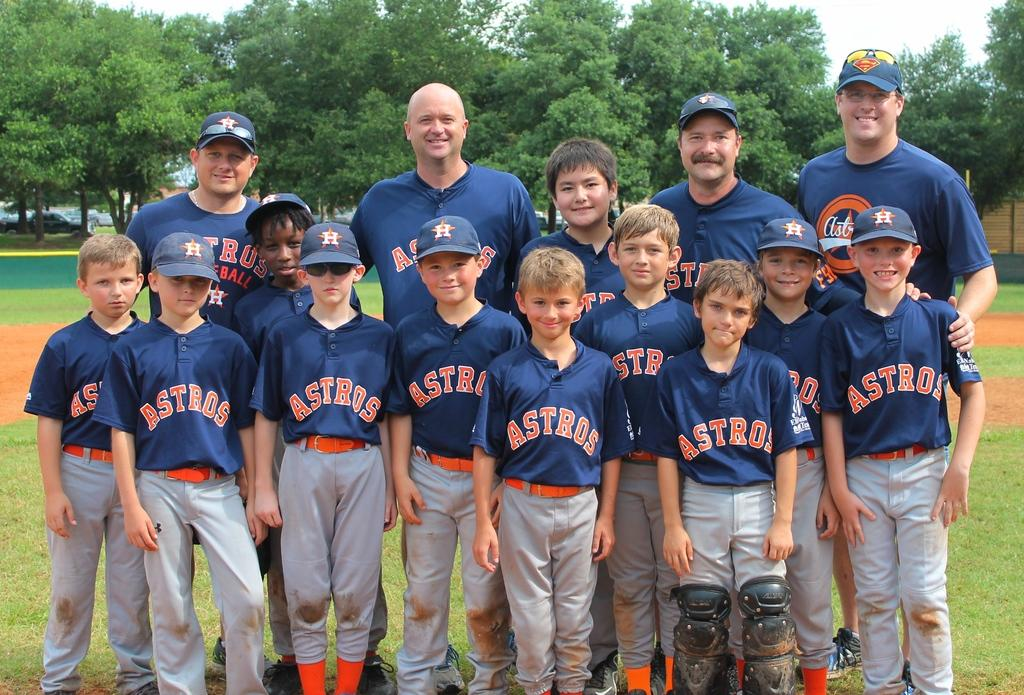<image>
Summarize the visual content of the image. A baseball team named the Astros posing for a team photo 